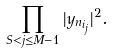Convert formula to latex. <formula><loc_0><loc_0><loc_500><loc_500>\prod _ { S < j \leq M - 1 } | y _ { n _ { i _ { j } } } | ^ { 2 } .</formula> 